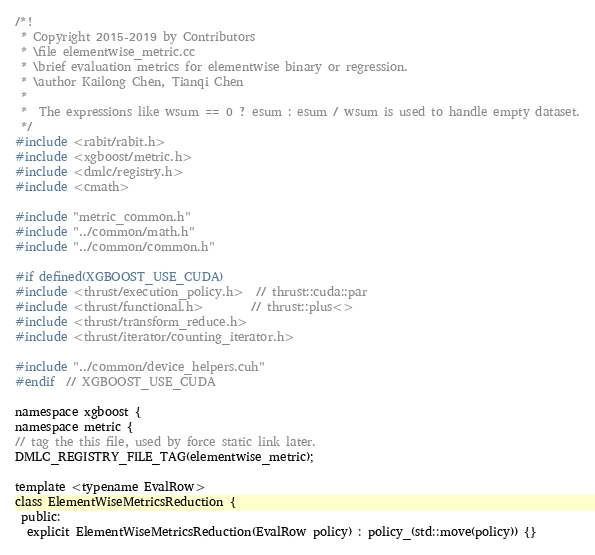Convert code to text. <code><loc_0><loc_0><loc_500><loc_500><_Cuda_>/*!
 * Copyright 2015-2019 by Contributors
 * \file elementwise_metric.cc
 * \brief evaluation metrics for elementwise binary or regression.
 * \author Kailong Chen, Tianqi Chen
 *
 *  The expressions like wsum == 0 ? esum : esum / wsum is used to handle empty dataset.
 */
#include <rabit/rabit.h>
#include <xgboost/metric.h>
#include <dmlc/registry.h>
#include <cmath>

#include "metric_common.h"
#include "../common/math.h"
#include "../common/common.h"

#if defined(XGBOOST_USE_CUDA)
#include <thrust/execution_policy.h>  // thrust::cuda::par
#include <thrust/functional.h>        // thrust::plus<>
#include <thrust/transform_reduce.h>
#include <thrust/iterator/counting_iterator.h>

#include "../common/device_helpers.cuh"
#endif  // XGBOOST_USE_CUDA

namespace xgboost {
namespace metric {
// tag the this file, used by force static link later.
DMLC_REGISTRY_FILE_TAG(elementwise_metric);

template <typename EvalRow>
class ElementWiseMetricsReduction {
 public:
  explicit ElementWiseMetricsReduction(EvalRow policy) : policy_(std::move(policy)) {}
</code> 